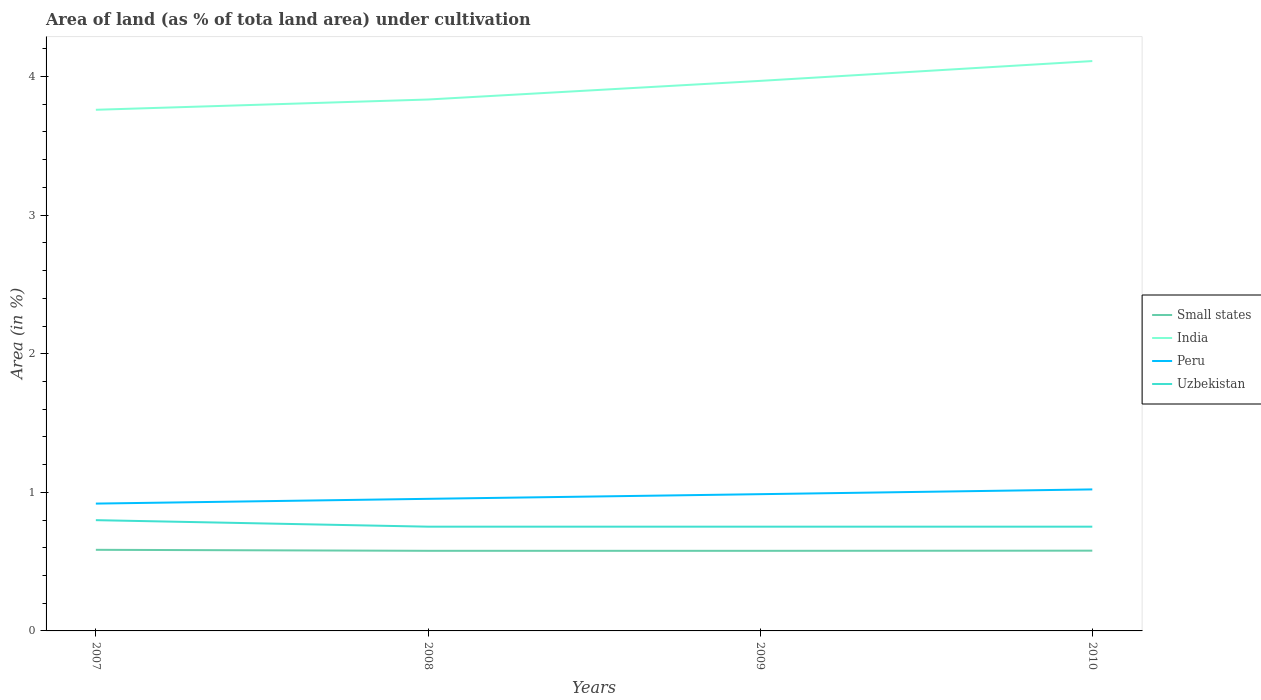How many different coloured lines are there?
Ensure brevity in your answer.  4. Does the line corresponding to India intersect with the line corresponding to Peru?
Provide a succinct answer. No. Across all years, what is the maximum percentage of land under cultivation in Small states?
Your answer should be compact. 0.58. What is the total percentage of land under cultivation in Small states in the graph?
Give a very brief answer. 0.01. What is the difference between the highest and the second highest percentage of land under cultivation in India?
Offer a very short reply. 0.35. What is the difference between the highest and the lowest percentage of land under cultivation in India?
Make the answer very short. 2. How many years are there in the graph?
Offer a terse response. 4. What is the difference between two consecutive major ticks on the Y-axis?
Ensure brevity in your answer.  1. Are the values on the major ticks of Y-axis written in scientific E-notation?
Your answer should be compact. No. Where does the legend appear in the graph?
Give a very brief answer. Center right. How are the legend labels stacked?
Offer a very short reply. Vertical. What is the title of the graph?
Offer a very short reply. Area of land (as % of tota land area) under cultivation. Does "Puerto Rico" appear as one of the legend labels in the graph?
Offer a terse response. No. What is the label or title of the Y-axis?
Your answer should be very brief. Area (in %). What is the Area (in %) of Small states in 2007?
Provide a succinct answer. 0.59. What is the Area (in %) in India in 2007?
Give a very brief answer. 3.76. What is the Area (in %) of Peru in 2007?
Your response must be concise. 0.92. What is the Area (in %) in Uzbekistan in 2007?
Keep it short and to the point. 0.8. What is the Area (in %) in Small states in 2008?
Provide a succinct answer. 0.58. What is the Area (in %) of India in 2008?
Make the answer very short. 3.83. What is the Area (in %) of Peru in 2008?
Offer a terse response. 0.95. What is the Area (in %) in Uzbekistan in 2008?
Provide a short and direct response. 0.75. What is the Area (in %) in Small states in 2009?
Ensure brevity in your answer.  0.58. What is the Area (in %) of India in 2009?
Your response must be concise. 3.97. What is the Area (in %) in Peru in 2009?
Provide a succinct answer. 0.99. What is the Area (in %) in Uzbekistan in 2009?
Keep it short and to the point. 0.75. What is the Area (in %) in Small states in 2010?
Keep it short and to the point. 0.58. What is the Area (in %) in India in 2010?
Offer a terse response. 4.11. What is the Area (in %) in Peru in 2010?
Your answer should be very brief. 1.02. What is the Area (in %) of Uzbekistan in 2010?
Make the answer very short. 0.75. Across all years, what is the maximum Area (in %) of Small states?
Your answer should be very brief. 0.59. Across all years, what is the maximum Area (in %) in India?
Make the answer very short. 4.11. Across all years, what is the maximum Area (in %) in Peru?
Your response must be concise. 1.02. Across all years, what is the maximum Area (in %) of Uzbekistan?
Offer a terse response. 0.8. Across all years, what is the minimum Area (in %) of Small states?
Keep it short and to the point. 0.58. Across all years, what is the minimum Area (in %) in India?
Ensure brevity in your answer.  3.76. Across all years, what is the minimum Area (in %) of Peru?
Offer a terse response. 0.92. Across all years, what is the minimum Area (in %) in Uzbekistan?
Ensure brevity in your answer.  0.75. What is the total Area (in %) of Small states in the graph?
Your answer should be compact. 2.32. What is the total Area (in %) in India in the graph?
Give a very brief answer. 15.68. What is the total Area (in %) of Peru in the graph?
Offer a terse response. 3.88. What is the total Area (in %) in Uzbekistan in the graph?
Provide a short and direct response. 3.06. What is the difference between the Area (in %) of Small states in 2007 and that in 2008?
Offer a terse response. 0.01. What is the difference between the Area (in %) in India in 2007 and that in 2008?
Ensure brevity in your answer.  -0.07. What is the difference between the Area (in %) of Peru in 2007 and that in 2008?
Provide a short and direct response. -0.03. What is the difference between the Area (in %) in Uzbekistan in 2007 and that in 2008?
Your response must be concise. 0.05. What is the difference between the Area (in %) in Small states in 2007 and that in 2009?
Provide a short and direct response. 0.01. What is the difference between the Area (in %) of India in 2007 and that in 2009?
Offer a terse response. -0.21. What is the difference between the Area (in %) in Peru in 2007 and that in 2009?
Give a very brief answer. -0.07. What is the difference between the Area (in %) of Uzbekistan in 2007 and that in 2009?
Make the answer very short. 0.05. What is the difference between the Area (in %) of Small states in 2007 and that in 2010?
Ensure brevity in your answer.  0.01. What is the difference between the Area (in %) of India in 2007 and that in 2010?
Keep it short and to the point. -0.35. What is the difference between the Area (in %) of Peru in 2007 and that in 2010?
Give a very brief answer. -0.1. What is the difference between the Area (in %) in Uzbekistan in 2007 and that in 2010?
Keep it short and to the point. 0.05. What is the difference between the Area (in %) in Small states in 2008 and that in 2009?
Your response must be concise. 0. What is the difference between the Area (in %) of India in 2008 and that in 2009?
Provide a short and direct response. -0.13. What is the difference between the Area (in %) of Peru in 2008 and that in 2009?
Offer a very short reply. -0.03. What is the difference between the Area (in %) in Uzbekistan in 2008 and that in 2009?
Offer a terse response. 0. What is the difference between the Area (in %) of Small states in 2008 and that in 2010?
Provide a succinct answer. -0. What is the difference between the Area (in %) in India in 2008 and that in 2010?
Keep it short and to the point. -0.28. What is the difference between the Area (in %) of Peru in 2008 and that in 2010?
Keep it short and to the point. -0.07. What is the difference between the Area (in %) of Small states in 2009 and that in 2010?
Provide a succinct answer. -0. What is the difference between the Area (in %) of India in 2009 and that in 2010?
Provide a short and direct response. -0.14. What is the difference between the Area (in %) in Peru in 2009 and that in 2010?
Make the answer very short. -0.03. What is the difference between the Area (in %) of Uzbekistan in 2009 and that in 2010?
Provide a short and direct response. 0. What is the difference between the Area (in %) of Small states in 2007 and the Area (in %) of India in 2008?
Make the answer very short. -3.25. What is the difference between the Area (in %) of Small states in 2007 and the Area (in %) of Peru in 2008?
Provide a succinct answer. -0.37. What is the difference between the Area (in %) of Small states in 2007 and the Area (in %) of Uzbekistan in 2008?
Keep it short and to the point. -0.17. What is the difference between the Area (in %) of India in 2007 and the Area (in %) of Peru in 2008?
Keep it short and to the point. 2.81. What is the difference between the Area (in %) of India in 2007 and the Area (in %) of Uzbekistan in 2008?
Ensure brevity in your answer.  3.01. What is the difference between the Area (in %) in Peru in 2007 and the Area (in %) in Uzbekistan in 2008?
Your response must be concise. 0.17. What is the difference between the Area (in %) of Small states in 2007 and the Area (in %) of India in 2009?
Provide a succinct answer. -3.38. What is the difference between the Area (in %) in Small states in 2007 and the Area (in %) in Peru in 2009?
Ensure brevity in your answer.  -0.4. What is the difference between the Area (in %) in Small states in 2007 and the Area (in %) in Uzbekistan in 2009?
Ensure brevity in your answer.  -0.17. What is the difference between the Area (in %) in India in 2007 and the Area (in %) in Peru in 2009?
Ensure brevity in your answer.  2.77. What is the difference between the Area (in %) in India in 2007 and the Area (in %) in Uzbekistan in 2009?
Provide a short and direct response. 3.01. What is the difference between the Area (in %) in Peru in 2007 and the Area (in %) in Uzbekistan in 2009?
Keep it short and to the point. 0.17. What is the difference between the Area (in %) of Small states in 2007 and the Area (in %) of India in 2010?
Provide a succinct answer. -3.53. What is the difference between the Area (in %) of Small states in 2007 and the Area (in %) of Peru in 2010?
Offer a very short reply. -0.44. What is the difference between the Area (in %) in Small states in 2007 and the Area (in %) in Uzbekistan in 2010?
Provide a succinct answer. -0.17. What is the difference between the Area (in %) of India in 2007 and the Area (in %) of Peru in 2010?
Your answer should be very brief. 2.74. What is the difference between the Area (in %) of India in 2007 and the Area (in %) of Uzbekistan in 2010?
Make the answer very short. 3.01. What is the difference between the Area (in %) of Peru in 2007 and the Area (in %) of Uzbekistan in 2010?
Offer a very short reply. 0.17. What is the difference between the Area (in %) in Small states in 2008 and the Area (in %) in India in 2009?
Your response must be concise. -3.39. What is the difference between the Area (in %) of Small states in 2008 and the Area (in %) of Peru in 2009?
Provide a succinct answer. -0.41. What is the difference between the Area (in %) of Small states in 2008 and the Area (in %) of Uzbekistan in 2009?
Provide a succinct answer. -0.17. What is the difference between the Area (in %) of India in 2008 and the Area (in %) of Peru in 2009?
Your response must be concise. 2.85. What is the difference between the Area (in %) in India in 2008 and the Area (in %) in Uzbekistan in 2009?
Ensure brevity in your answer.  3.08. What is the difference between the Area (in %) of Peru in 2008 and the Area (in %) of Uzbekistan in 2009?
Provide a short and direct response. 0.2. What is the difference between the Area (in %) in Small states in 2008 and the Area (in %) in India in 2010?
Provide a short and direct response. -3.53. What is the difference between the Area (in %) in Small states in 2008 and the Area (in %) in Peru in 2010?
Your answer should be very brief. -0.44. What is the difference between the Area (in %) of Small states in 2008 and the Area (in %) of Uzbekistan in 2010?
Your answer should be compact. -0.17. What is the difference between the Area (in %) in India in 2008 and the Area (in %) in Peru in 2010?
Your response must be concise. 2.81. What is the difference between the Area (in %) of India in 2008 and the Area (in %) of Uzbekistan in 2010?
Offer a terse response. 3.08. What is the difference between the Area (in %) of Peru in 2008 and the Area (in %) of Uzbekistan in 2010?
Ensure brevity in your answer.  0.2. What is the difference between the Area (in %) of Small states in 2009 and the Area (in %) of India in 2010?
Provide a succinct answer. -3.53. What is the difference between the Area (in %) in Small states in 2009 and the Area (in %) in Peru in 2010?
Give a very brief answer. -0.44. What is the difference between the Area (in %) of Small states in 2009 and the Area (in %) of Uzbekistan in 2010?
Offer a terse response. -0.17. What is the difference between the Area (in %) of India in 2009 and the Area (in %) of Peru in 2010?
Provide a short and direct response. 2.95. What is the difference between the Area (in %) of India in 2009 and the Area (in %) of Uzbekistan in 2010?
Your answer should be very brief. 3.22. What is the difference between the Area (in %) in Peru in 2009 and the Area (in %) in Uzbekistan in 2010?
Your answer should be very brief. 0.23. What is the average Area (in %) in Small states per year?
Ensure brevity in your answer.  0.58. What is the average Area (in %) of India per year?
Offer a very short reply. 3.92. What is the average Area (in %) of Peru per year?
Give a very brief answer. 0.97. What is the average Area (in %) of Uzbekistan per year?
Offer a very short reply. 0.76. In the year 2007, what is the difference between the Area (in %) of Small states and Area (in %) of India?
Give a very brief answer. -3.17. In the year 2007, what is the difference between the Area (in %) in Small states and Area (in %) in Peru?
Your answer should be very brief. -0.33. In the year 2007, what is the difference between the Area (in %) in Small states and Area (in %) in Uzbekistan?
Your answer should be compact. -0.21. In the year 2007, what is the difference between the Area (in %) in India and Area (in %) in Peru?
Offer a terse response. 2.84. In the year 2007, what is the difference between the Area (in %) of India and Area (in %) of Uzbekistan?
Provide a short and direct response. 2.96. In the year 2007, what is the difference between the Area (in %) in Peru and Area (in %) in Uzbekistan?
Keep it short and to the point. 0.12. In the year 2008, what is the difference between the Area (in %) of Small states and Area (in %) of India?
Make the answer very short. -3.26. In the year 2008, what is the difference between the Area (in %) in Small states and Area (in %) in Peru?
Provide a short and direct response. -0.38. In the year 2008, what is the difference between the Area (in %) of Small states and Area (in %) of Uzbekistan?
Your response must be concise. -0.17. In the year 2008, what is the difference between the Area (in %) of India and Area (in %) of Peru?
Your response must be concise. 2.88. In the year 2008, what is the difference between the Area (in %) in India and Area (in %) in Uzbekistan?
Offer a terse response. 3.08. In the year 2008, what is the difference between the Area (in %) of Peru and Area (in %) of Uzbekistan?
Provide a short and direct response. 0.2. In the year 2009, what is the difference between the Area (in %) in Small states and Area (in %) in India?
Offer a terse response. -3.39. In the year 2009, what is the difference between the Area (in %) of Small states and Area (in %) of Peru?
Make the answer very short. -0.41. In the year 2009, what is the difference between the Area (in %) in Small states and Area (in %) in Uzbekistan?
Make the answer very short. -0.17. In the year 2009, what is the difference between the Area (in %) of India and Area (in %) of Peru?
Your answer should be compact. 2.98. In the year 2009, what is the difference between the Area (in %) of India and Area (in %) of Uzbekistan?
Offer a terse response. 3.22. In the year 2009, what is the difference between the Area (in %) of Peru and Area (in %) of Uzbekistan?
Keep it short and to the point. 0.23. In the year 2010, what is the difference between the Area (in %) of Small states and Area (in %) of India?
Your answer should be very brief. -3.53. In the year 2010, what is the difference between the Area (in %) in Small states and Area (in %) in Peru?
Provide a succinct answer. -0.44. In the year 2010, what is the difference between the Area (in %) in Small states and Area (in %) in Uzbekistan?
Make the answer very short. -0.17. In the year 2010, what is the difference between the Area (in %) in India and Area (in %) in Peru?
Your response must be concise. 3.09. In the year 2010, what is the difference between the Area (in %) in India and Area (in %) in Uzbekistan?
Keep it short and to the point. 3.36. In the year 2010, what is the difference between the Area (in %) of Peru and Area (in %) of Uzbekistan?
Your answer should be very brief. 0.27. What is the ratio of the Area (in %) in Small states in 2007 to that in 2008?
Provide a succinct answer. 1.01. What is the ratio of the Area (in %) in India in 2007 to that in 2008?
Offer a very short reply. 0.98. What is the ratio of the Area (in %) of Peru in 2007 to that in 2008?
Provide a short and direct response. 0.96. What is the ratio of the Area (in %) in Uzbekistan in 2007 to that in 2008?
Make the answer very short. 1.06. What is the ratio of the Area (in %) of Small states in 2007 to that in 2009?
Your answer should be very brief. 1.01. What is the ratio of the Area (in %) in India in 2007 to that in 2009?
Provide a short and direct response. 0.95. What is the ratio of the Area (in %) of Peru in 2007 to that in 2009?
Offer a terse response. 0.93. What is the ratio of the Area (in %) of Small states in 2007 to that in 2010?
Provide a short and direct response. 1.01. What is the ratio of the Area (in %) of India in 2007 to that in 2010?
Offer a very short reply. 0.91. What is the ratio of the Area (in %) of Peru in 2007 to that in 2010?
Your answer should be compact. 0.9. What is the ratio of the Area (in %) of Uzbekistan in 2007 to that in 2010?
Provide a short and direct response. 1.06. What is the ratio of the Area (in %) in Small states in 2008 to that in 2009?
Give a very brief answer. 1. What is the ratio of the Area (in %) of India in 2008 to that in 2009?
Make the answer very short. 0.97. What is the ratio of the Area (in %) of Peru in 2008 to that in 2009?
Offer a terse response. 0.97. What is the ratio of the Area (in %) in Small states in 2008 to that in 2010?
Your response must be concise. 1. What is the ratio of the Area (in %) in India in 2008 to that in 2010?
Give a very brief answer. 0.93. What is the ratio of the Area (in %) of Peru in 2008 to that in 2010?
Provide a succinct answer. 0.93. What is the ratio of the Area (in %) in India in 2009 to that in 2010?
Keep it short and to the point. 0.97. What is the ratio of the Area (in %) in Peru in 2009 to that in 2010?
Offer a terse response. 0.97. What is the ratio of the Area (in %) in Uzbekistan in 2009 to that in 2010?
Your response must be concise. 1. What is the difference between the highest and the second highest Area (in %) in Small states?
Keep it short and to the point. 0.01. What is the difference between the highest and the second highest Area (in %) of India?
Your answer should be very brief. 0.14. What is the difference between the highest and the second highest Area (in %) in Peru?
Offer a terse response. 0.03. What is the difference between the highest and the second highest Area (in %) of Uzbekistan?
Offer a very short reply. 0.05. What is the difference between the highest and the lowest Area (in %) in Small states?
Provide a short and direct response. 0.01. What is the difference between the highest and the lowest Area (in %) in India?
Offer a terse response. 0.35. What is the difference between the highest and the lowest Area (in %) of Peru?
Provide a short and direct response. 0.1. What is the difference between the highest and the lowest Area (in %) of Uzbekistan?
Your answer should be very brief. 0.05. 